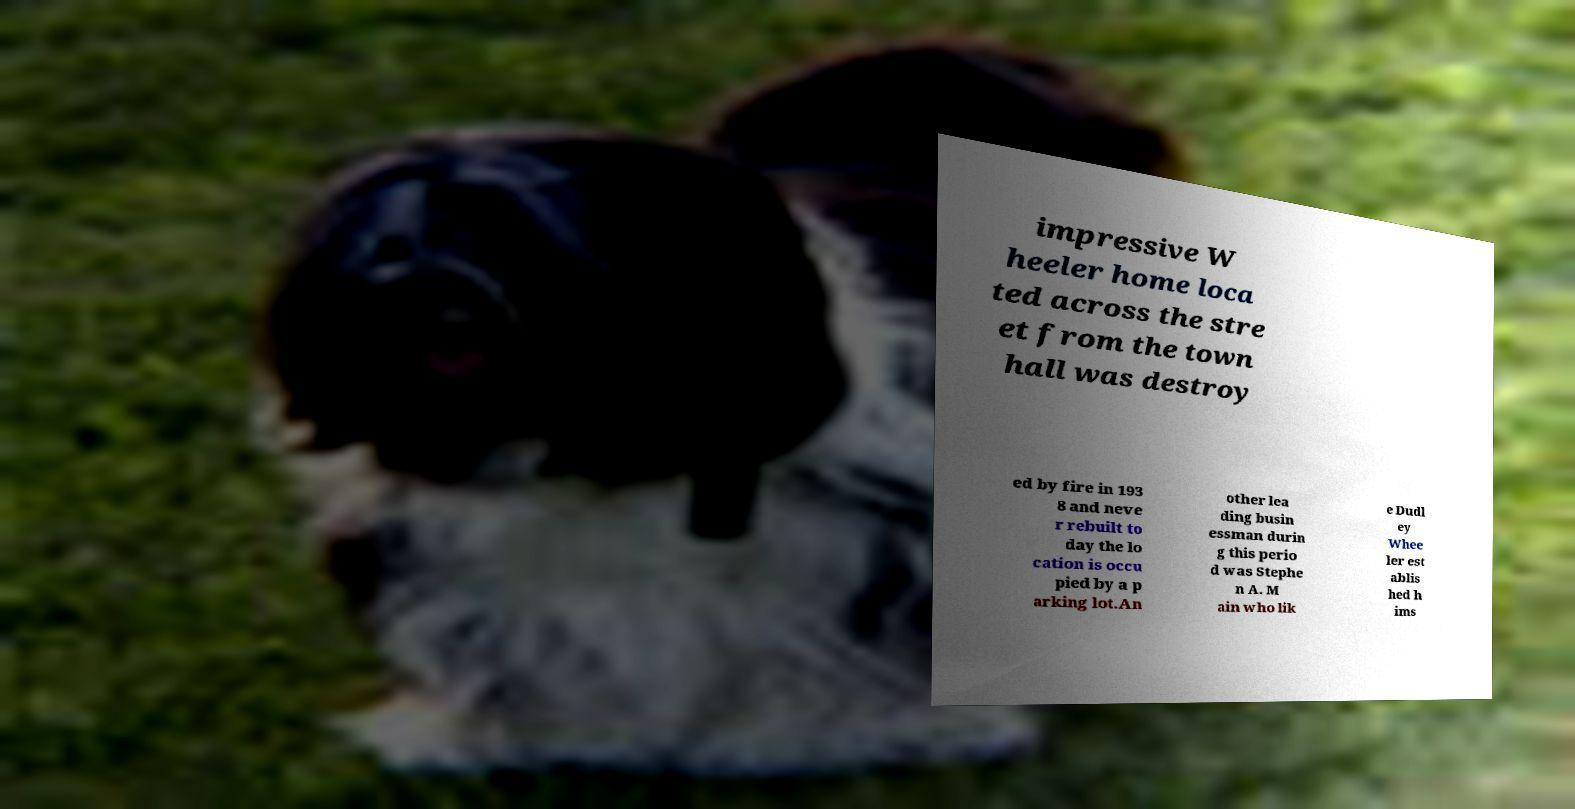Could you assist in decoding the text presented in this image and type it out clearly? impressive W heeler home loca ted across the stre et from the town hall was destroy ed by fire in 193 8 and neve r rebuilt to day the lo cation is occu pied by a p arking lot.An other lea ding busin essman durin g this perio d was Stephe n A. M ain who lik e Dudl ey Whee ler est ablis hed h ims 